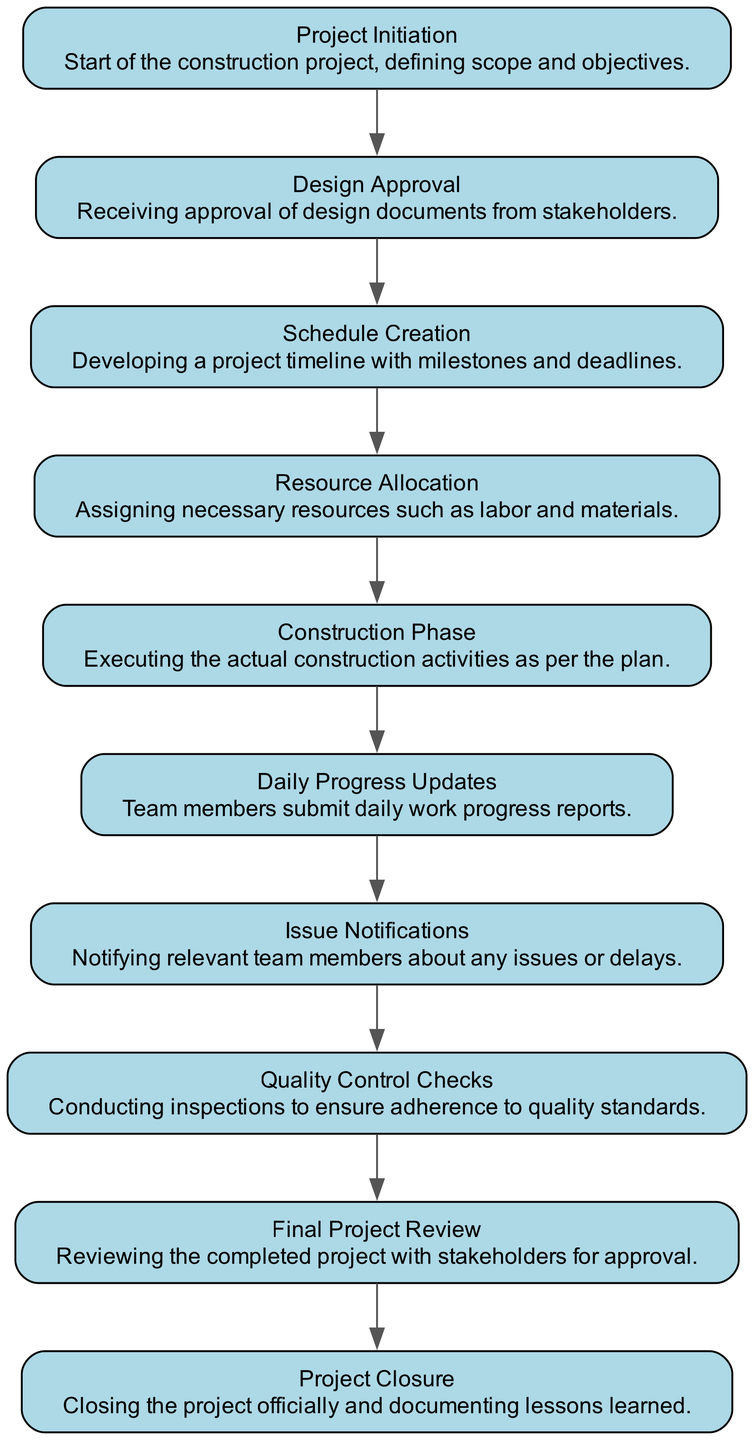What is the first task in the sequence? The first task in the sequence is "Project Initiation." This is determined by checking the starting point of the flow in the diagram.
Answer: Project Initiation How many nodes are in the diagram? To find the number of nodes, we count each individual node represented in the sequence diagram elements. There are ten distinct tasks shown.
Answer: 10 What is the task that follows Resource Allocation? According to the flow of the diagram, after "Resource Allocation," the next task is "Construction Phase." This is derived from the progression of tasks.
Answer: Construction Phase Which task is responsible for submitting daily work progress reports? The task dedicated to submitting daily work progress reports is "Daily Progress Updates." It can be identified as an element in the diagram's sequence.
Answer: Daily Progress Updates How many notifications are sent regarding issues? The issue notifications occur at one specific point in the sequence where the task "Issue Notifications" is represented. However, it does not specify the number of notifications. Thus, the answer is one occurrence of the task.
Answer: 1 What are the last two tasks in the sequence? The last two tasks in the sequence can be determined by looking at the end of the flow. They are "Final Project Review" and "Project Closure," which are the concluding tasks.
Answer: Final Project Review, Project Closure Which task ensures adherence to quality standards? The task that ensures adherence to quality standards is "Quality Control Checks." This can be identified from the list of nodes.
Answer: Quality Control Checks What is the relationship between Design Approval and Schedule Creation? The relationship is sequential, meaning that "Design Approval" must be completed before "Schedule Creation" can occur, as shown in the order of tasks.
Answer: Sequential Which task involves stakeholder approval? The task involving stakeholder approval is "Final Project Review." This task is specifically designed to review the project with stakeholders for their approval.
Answer: Final Project Review 